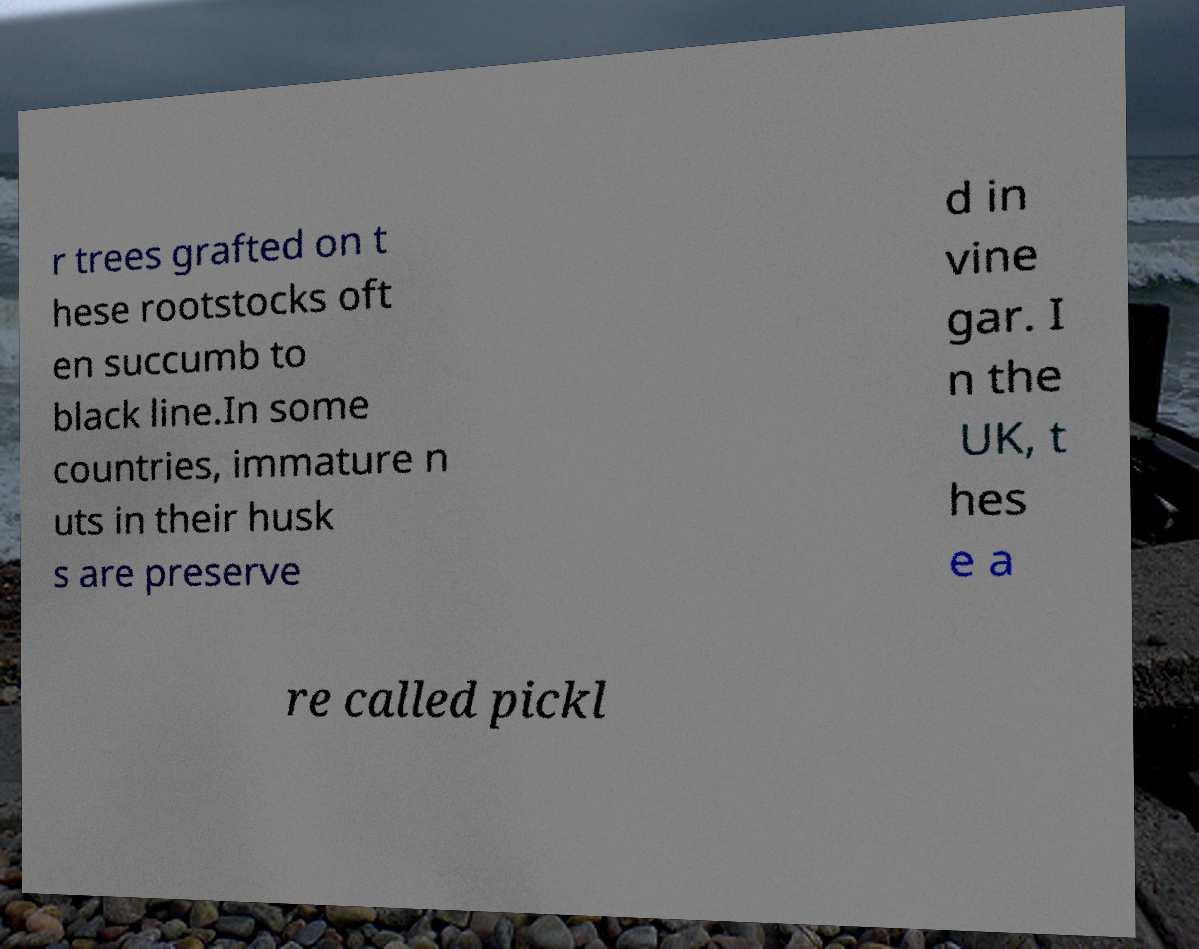For documentation purposes, I need the text within this image transcribed. Could you provide that? r trees grafted on t hese rootstocks oft en succumb to black line.In some countries, immature n uts in their husk s are preserve d in vine gar. I n the UK, t hes e a re called pickl 